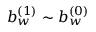Convert formula to latex. <formula><loc_0><loc_0><loc_500><loc_500>b _ { w } ^ { ( 1 ) } \sim b _ { w } ^ { ( 0 ) }</formula> 